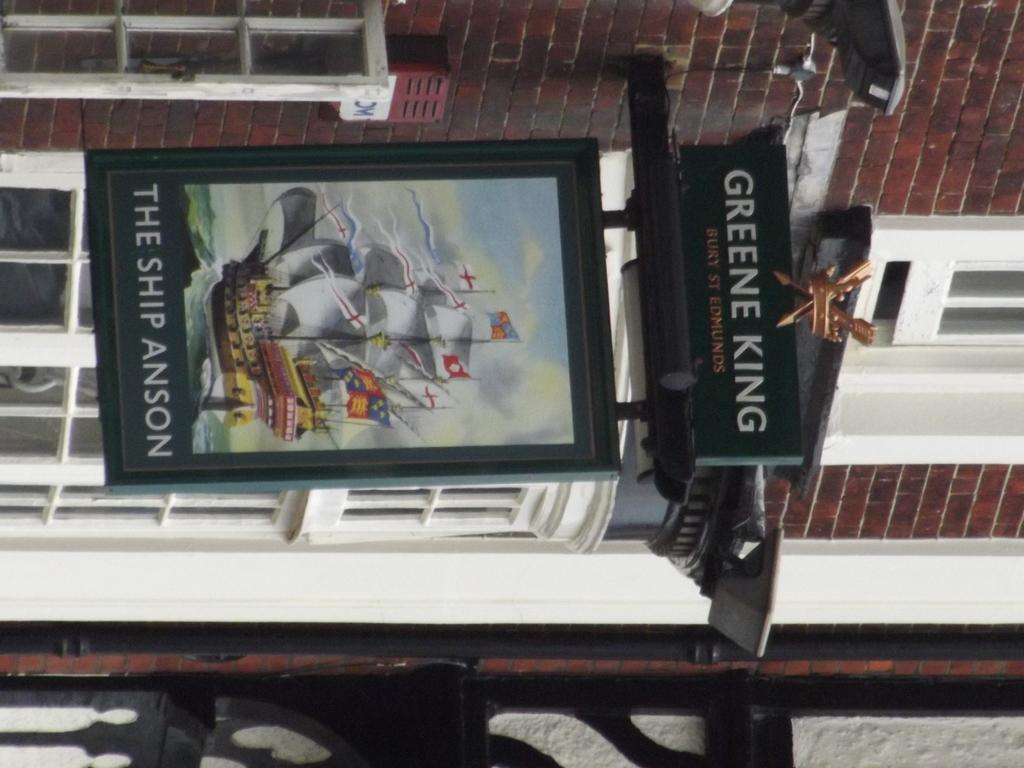<image>
Summarize the visual content of the image. A green poster containing the white text 'The Ship Anson'. 